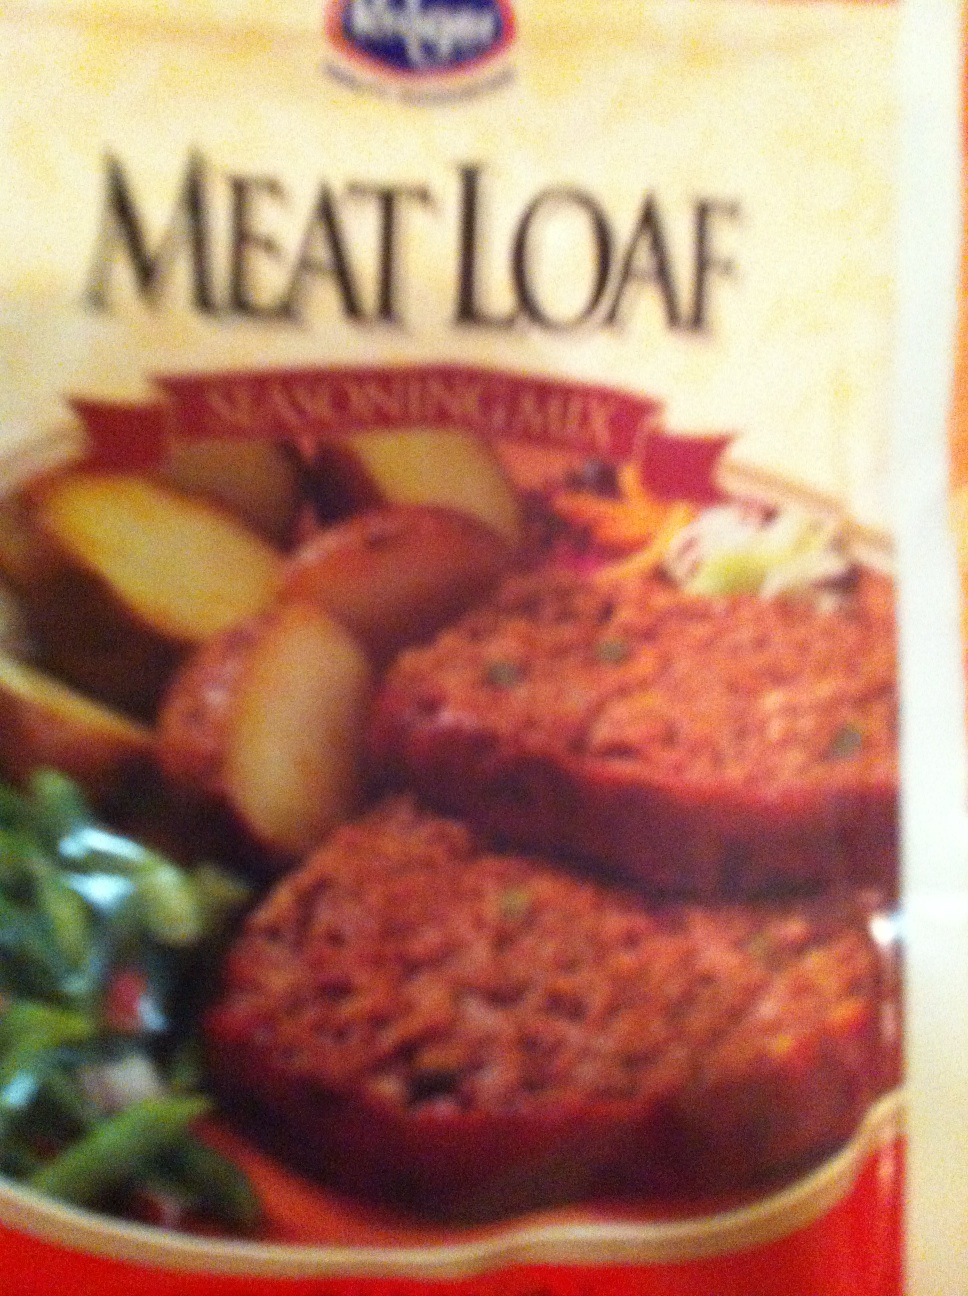Are there any dietary considerations for this product? Meatloaf generally contains ground meat, which may not be suitable for vegetarians or vegans. Additionally, it may contain wheat, eggs, and dairy, so it wouldn't be suitable for individuals with gluten, egg, or dairy allergies. It's best to check the package's ingredients list and nutrition facts to ensure it meets your dietary needs. 